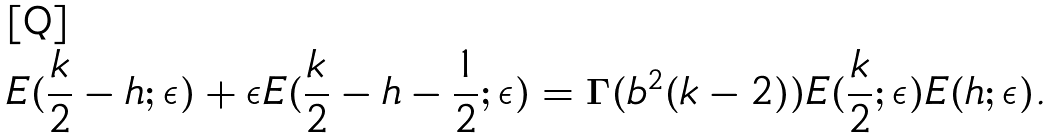Convert formula to latex. <formula><loc_0><loc_0><loc_500><loc_500>E ( \frac { k } { 2 } - h ; \epsilon ) + \epsilon E ( \frac { k } { 2 } - h - \frac { 1 } { 2 } ; \epsilon ) = \Gamma ( b ^ { 2 } ( k - 2 ) ) E ( \frac { k } { 2 } ; \epsilon ) E ( h ; \epsilon ) .</formula> 